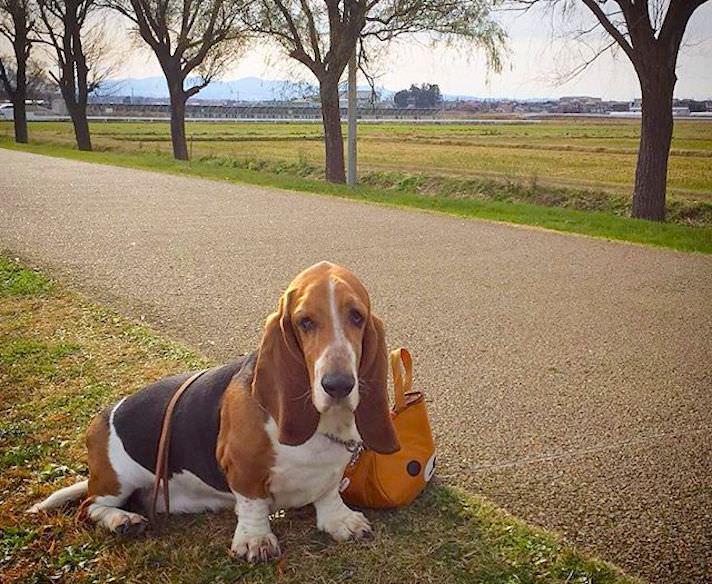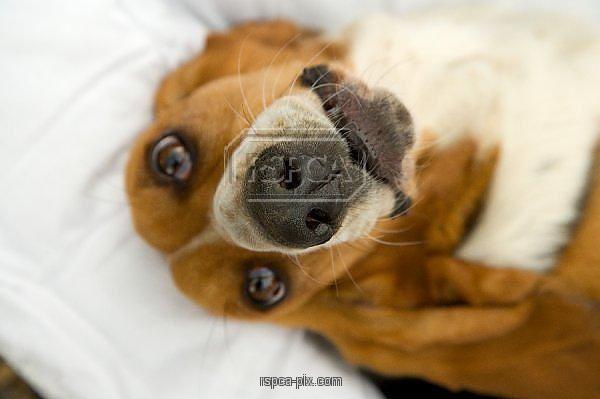The first image is the image on the left, the second image is the image on the right. For the images shown, is this caption "a dog has his head on a pillow" true? Answer yes or no. Yes. The first image is the image on the left, the second image is the image on the right. Examine the images to the left and right. Is the description "At least one dog is cuddling with a furry friend." accurate? Answer yes or no. No. 